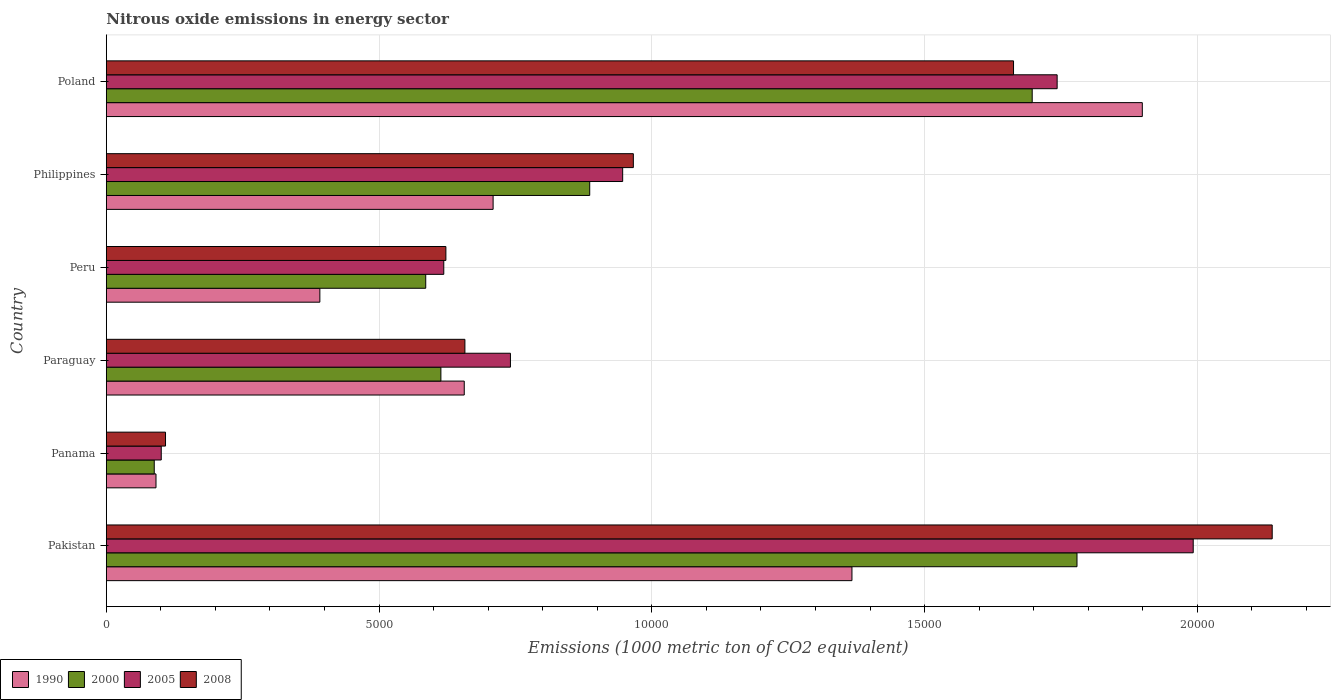How many different coloured bars are there?
Your answer should be compact. 4. How many groups of bars are there?
Your response must be concise. 6. Are the number of bars per tick equal to the number of legend labels?
Provide a succinct answer. Yes. How many bars are there on the 5th tick from the top?
Provide a succinct answer. 4. How many bars are there on the 3rd tick from the bottom?
Your answer should be compact. 4. In how many cases, is the number of bars for a given country not equal to the number of legend labels?
Give a very brief answer. 0. What is the amount of nitrous oxide emitted in 2005 in Panama?
Provide a succinct answer. 1006.8. Across all countries, what is the maximum amount of nitrous oxide emitted in 1990?
Keep it short and to the point. 1.90e+04. Across all countries, what is the minimum amount of nitrous oxide emitted in 1990?
Provide a succinct answer. 910.4. In which country was the amount of nitrous oxide emitted in 1990 minimum?
Ensure brevity in your answer.  Panama. What is the total amount of nitrous oxide emitted in 2008 in the graph?
Ensure brevity in your answer.  6.15e+04. What is the difference between the amount of nitrous oxide emitted in 1990 in Pakistan and that in Paraguay?
Your answer should be compact. 7107. What is the difference between the amount of nitrous oxide emitted in 2005 in Panama and the amount of nitrous oxide emitted in 2008 in Philippines?
Provide a succinct answer. -8654. What is the average amount of nitrous oxide emitted in 1990 per country?
Offer a very short reply. 8522.47. What is the difference between the amount of nitrous oxide emitted in 2000 and amount of nitrous oxide emitted in 2005 in Panama?
Your response must be concise. -128.4. What is the ratio of the amount of nitrous oxide emitted in 1990 in Paraguay to that in Philippines?
Your answer should be very brief. 0.93. Is the difference between the amount of nitrous oxide emitted in 2000 in Paraguay and Poland greater than the difference between the amount of nitrous oxide emitted in 2005 in Paraguay and Poland?
Provide a short and direct response. No. What is the difference between the highest and the second highest amount of nitrous oxide emitted in 2000?
Provide a succinct answer. 821. What is the difference between the highest and the lowest amount of nitrous oxide emitted in 1990?
Ensure brevity in your answer.  1.81e+04. What does the 4th bar from the top in Paraguay represents?
Keep it short and to the point. 1990. What does the 1st bar from the bottom in Philippines represents?
Make the answer very short. 1990. Is it the case that in every country, the sum of the amount of nitrous oxide emitted in 2000 and amount of nitrous oxide emitted in 2008 is greater than the amount of nitrous oxide emitted in 1990?
Give a very brief answer. Yes. How many bars are there?
Ensure brevity in your answer.  24. Are all the bars in the graph horizontal?
Provide a short and direct response. Yes. How many countries are there in the graph?
Your answer should be compact. 6. Does the graph contain any zero values?
Your answer should be very brief. No. Where does the legend appear in the graph?
Keep it short and to the point. Bottom left. What is the title of the graph?
Keep it short and to the point. Nitrous oxide emissions in energy sector. Does "1960" appear as one of the legend labels in the graph?
Give a very brief answer. No. What is the label or title of the X-axis?
Provide a succinct answer. Emissions (1000 metric ton of CO2 equivalent). What is the label or title of the Y-axis?
Make the answer very short. Country. What is the Emissions (1000 metric ton of CO2 equivalent) of 1990 in Pakistan?
Offer a very short reply. 1.37e+04. What is the Emissions (1000 metric ton of CO2 equivalent) of 2000 in Pakistan?
Give a very brief answer. 1.78e+04. What is the Emissions (1000 metric ton of CO2 equivalent) of 2005 in Pakistan?
Offer a very short reply. 1.99e+04. What is the Emissions (1000 metric ton of CO2 equivalent) of 2008 in Pakistan?
Your answer should be very brief. 2.14e+04. What is the Emissions (1000 metric ton of CO2 equivalent) in 1990 in Panama?
Ensure brevity in your answer.  910.4. What is the Emissions (1000 metric ton of CO2 equivalent) of 2000 in Panama?
Ensure brevity in your answer.  878.4. What is the Emissions (1000 metric ton of CO2 equivalent) in 2005 in Panama?
Provide a succinct answer. 1006.8. What is the Emissions (1000 metric ton of CO2 equivalent) of 2008 in Panama?
Provide a succinct answer. 1084.9. What is the Emissions (1000 metric ton of CO2 equivalent) in 1990 in Paraguay?
Provide a short and direct response. 6561.2. What is the Emissions (1000 metric ton of CO2 equivalent) of 2000 in Paraguay?
Give a very brief answer. 6132.8. What is the Emissions (1000 metric ton of CO2 equivalent) in 2005 in Paraguay?
Make the answer very short. 7407.7. What is the Emissions (1000 metric ton of CO2 equivalent) in 2008 in Paraguay?
Your answer should be very brief. 6573. What is the Emissions (1000 metric ton of CO2 equivalent) of 1990 in Peru?
Make the answer very short. 3914.1. What is the Emissions (1000 metric ton of CO2 equivalent) in 2000 in Peru?
Provide a succinct answer. 5854.9. What is the Emissions (1000 metric ton of CO2 equivalent) in 2005 in Peru?
Make the answer very short. 6185.8. What is the Emissions (1000 metric ton of CO2 equivalent) in 2008 in Peru?
Ensure brevity in your answer.  6224.5. What is the Emissions (1000 metric ton of CO2 equivalent) of 1990 in Philippines?
Make the answer very short. 7090.2. What is the Emissions (1000 metric ton of CO2 equivalent) of 2000 in Philippines?
Your response must be concise. 8861.1. What is the Emissions (1000 metric ton of CO2 equivalent) in 2005 in Philippines?
Offer a terse response. 9465.1. What is the Emissions (1000 metric ton of CO2 equivalent) in 2008 in Philippines?
Offer a terse response. 9660.8. What is the Emissions (1000 metric ton of CO2 equivalent) of 1990 in Poland?
Offer a very short reply. 1.90e+04. What is the Emissions (1000 metric ton of CO2 equivalent) of 2000 in Poland?
Your response must be concise. 1.70e+04. What is the Emissions (1000 metric ton of CO2 equivalent) in 2005 in Poland?
Your answer should be compact. 1.74e+04. What is the Emissions (1000 metric ton of CO2 equivalent) in 2008 in Poland?
Offer a terse response. 1.66e+04. Across all countries, what is the maximum Emissions (1000 metric ton of CO2 equivalent) in 1990?
Your answer should be compact. 1.90e+04. Across all countries, what is the maximum Emissions (1000 metric ton of CO2 equivalent) of 2000?
Offer a terse response. 1.78e+04. Across all countries, what is the maximum Emissions (1000 metric ton of CO2 equivalent) of 2005?
Offer a terse response. 1.99e+04. Across all countries, what is the maximum Emissions (1000 metric ton of CO2 equivalent) in 2008?
Your answer should be compact. 2.14e+04. Across all countries, what is the minimum Emissions (1000 metric ton of CO2 equivalent) of 1990?
Keep it short and to the point. 910.4. Across all countries, what is the minimum Emissions (1000 metric ton of CO2 equivalent) in 2000?
Provide a short and direct response. 878.4. Across all countries, what is the minimum Emissions (1000 metric ton of CO2 equivalent) of 2005?
Provide a succinct answer. 1006.8. Across all countries, what is the minimum Emissions (1000 metric ton of CO2 equivalent) in 2008?
Your response must be concise. 1084.9. What is the total Emissions (1000 metric ton of CO2 equivalent) in 1990 in the graph?
Your response must be concise. 5.11e+04. What is the total Emissions (1000 metric ton of CO2 equivalent) in 2000 in the graph?
Your answer should be very brief. 5.65e+04. What is the total Emissions (1000 metric ton of CO2 equivalent) in 2005 in the graph?
Your answer should be compact. 6.14e+04. What is the total Emissions (1000 metric ton of CO2 equivalent) of 2008 in the graph?
Give a very brief answer. 6.15e+04. What is the difference between the Emissions (1000 metric ton of CO2 equivalent) in 1990 in Pakistan and that in Panama?
Your response must be concise. 1.28e+04. What is the difference between the Emissions (1000 metric ton of CO2 equivalent) in 2000 in Pakistan and that in Panama?
Offer a terse response. 1.69e+04. What is the difference between the Emissions (1000 metric ton of CO2 equivalent) in 2005 in Pakistan and that in Panama?
Your answer should be very brief. 1.89e+04. What is the difference between the Emissions (1000 metric ton of CO2 equivalent) of 2008 in Pakistan and that in Panama?
Provide a succinct answer. 2.03e+04. What is the difference between the Emissions (1000 metric ton of CO2 equivalent) in 1990 in Pakistan and that in Paraguay?
Give a very brief answer. 7107. What is the difference between the Emissions (1000 metric ton of CO2 equivalent) of 2000 in Pakistan and that in Paraguay?
Make the answer very short. 1.17e+04. What is the difference between the Emissions (1000 metric ton of CO2 equivalent) in 2005 in Pakistan and that in Paraguay?
Ensure brevity in your answer.  1.25e+04. What is the difference between the Emissions (1000 metric ton of CO2 equivalent) of 2008 in Pakistan and that in Paraguay?
Offer a very short reply. 1.48e+04. What is the difference between the Emissions (1000 metric ton of CO2 equivalent) of 1990 in Pakistan and that in Peru?
Make the answer very short. 9754.1. What is the difference between the Emissions (1000 metric ton of CO2 equivalent) in 2000 in Pakistan and that in Peru?
Your response must be concise. 1.19e+04. What is the difference between the Emissions (1000 metric ton of CO2 equivalent) of 2005 in Pakistan and that in Peru?
Give a very brief answer. 1.37e+04. What is the difference between the Emissions (1000 metric ton of CO2 equivalent) in 2008 in Pakistan and that in Peru?
Your answer should be very brief. 1.51e+04. What is the difference between the Emissions (1000 metric ton of CO2 equivalent) in 1990 in Pakistan and that in Philippines?
Ensure brevity in your answer.  6578. What is the difference between the Emissions (1000 metric ton of CO2 equivalent) of 2000 in Pakistan and that in Philippines?
Offer a very short reply. 8932.4. What is the difference between the Emissions (1000 metric ton of CO2 equivalent) in 2005 in Pakistan and that in Philippines?
Make the answer very short. 1.05e+04. What is the difference between the Emissions (1000 metric ton of CO2 equivalent) in 2008 in Pakistan and that in Philippines?
Offer a very short reply. 1.17e+04. What is the difference between the Emissions (1000 metric ton of CO2 equivalent) of 1990 in Pakistan and that in Poland?
Offer a very short reply. -5322.5. What is the difference between the Emissions (1000 metric ton of CO2 equivalent) in 2000 in Pakistan and that in Poland?
Ensure brevity in your answer.  821. What is the difference between the Emissions (1000 metric ton of CO2 equivalent) of 2005 in Pakistan and that in Poland?
Make the answer very short. 2494.4. What is the difference between the Emissions (1000 metric ton of CO2 equivalent) of 2008 in Pakistan and that in Poland?
Give a very brief answer. 4741.7. What is the difference between the Emissions (1000 metric ton of CO2 equivalent) in 1990 in Panama and that in Paraguay?
Your answer should be compact. -5650.8. What is the difference between the Emissions (1000 metric ton of CO2 equivalent) of 2000 in Panama and that in Paraguay?
Offer a terse response. -5254.4. What is the difference between the Emissions (1000 metric ton of CO2 equivalent) of 2005 in Panama and that in Paraguay?
Your response must be concise. -6400.9. What is the difference between the Emissions (1000 metric ton of CO2 equivalent) in 2008 in Panama and that in Paraguay?
Keep it short and to the point. -5488.1. What is the difference between the Emissions (1000 metric ton of CO2 equivalent) in 1990 in Panama and that in Peru?
Your response must be concise. -3003.7. What is the difference between the Emissions (1000 metric ton of CO2 equivalent) in 2000 in Panama and that in Peru?
Make the answer very short. -4976.5. What is the difference between the Emissions (1000 metric ton of CO2 equivalent) of 2005 in Panama and that in Peru?
Provide a short and direct response. -5179. What is the difference between the Emissions (1000 metric ton of CO2 equivalent) of 2008 in Panama and that in Peru?
Make the answer very short. -5139.6. What is the difference between the Emissions (1000 metric ton of CO2 equivalent) of 1990 in Panama and that in Philippines?
Offer a terse response. -6179.8. What is the difference between the Emissions (1000 metric ton of CO2 equivalent) of 2000 in Panama and that in Philippines?
Your answer should be compact. -7982.7. What is the difference between the Emissions (1000 metric ton of CO2 equivalent) in 2005 in Panama and that in Philippines?
Your answer should be compact. -8458.3. What is the difference between the Emissions (1000 metric ton of CO2 equivalent) of 2008 in Panama and that in Philippines?
Keep it short and to the point. -8575.9. What is the difference between the Emissions (1000 metric ton of CO2 equivalent) in 1990 in Panama and that in Poland?
Your answer should be compact. -1.81e+04. What is the difference between the Emissions (1000 metric ton of CO2 equivalent) in 2000 in Panama and that in Poland?
Your answer should be compact. -1.61e+04. What is the difference between the Emissions (1000 metric ton of CO2 equivalent) of 2005 in Panama and that in Poland?
Your answer should be very brief. -1.64e+04. What is the difference between the Emissions (1000 metric ton of CO2 equivalent) of 2008 in Panama and that in Poland?
Ensure brevity in your answer.  -1.55e+04. What is the difference between the Emissions (1000 metric ton of CO2 equivalent) in 1990 in Paraguay and that in Peru?
Make the answer very short. 2647.1. What is the difference between the Emissions (1000 metric ton of CO2 equivalent) of 2000 in Paraguay and that in Peru?
Provide a short and direct response. 277.9. What is the difference between the Emissions (1000 metric ton of CO2 equivalent) in 2005 in Paraguay and that in Peru?
Keep it short and to the point. 1221.9. What is the difference between the Emissions (1000 metric ton of CO2 equivalent) of 2008 in Paraguay and that in Peru?
Give a very brief answer. 348.5. What is the difference between the Emissions (1000 metric ton of CO2 equivalent) in 1990 in Paraguay and that in Philippines?
Provide a succinct answer. -529. What is the difference between the Emissions (1000 metric ton of CO2 equivalent) of 2000 in Paraguay and that in Philippines?
Keep it short and to the point. -2728.3. What is the difference between the Emissions (1000 metric ton of CO2 equivalent) of 2005 in Paraguay and that in Philippines?
Ensure brevity in your answer.  -2057.4. What is the difference between the Emissions (1000 metric ton of CO2 equivalent) in 2008 in Paraguay and that in Philippines?
Your response must be concise. -3087.8. What is the difference between the Emissions (1000 metric ton of CO2 equivalent) in 1990 in Paraguay and that in Poland?
Give a very brief answer. -1.24e+04. What is the difference between the Emissions (1000 metric ton of CO2 equivalent) in 2000 in Paraguay and that in Poland?
Your response must be concise. -1.08e+04. What is the difference between the Emissions (1000 metric ton of CO2 equivalent) in 2005 in Paraguay and that in Poland?
Offer a very short reply. -1.00e+04. What is the difference between the Emissions (1000 metric ton of CO2 equivalent) of 2008 in Paraguay and that in Poland?
Provide a short and direct response. -1.01e+04. What is the difference between the Emissions (1000 metric ton of CO2 equivalent) in 1990 in Peru and that in Philippines?
Offer a very short reply. -3176.1. What is the difference between the Emissions (1000 metric ton of CO2 equivalent) in 2000 in Peru and that in Philippines?
Provide a succinct answer. -3006.2. What is the difference between the Emissions (1000 metric ton of CO2 equivalent) of 2005 in Peru and that in Philippines?
Ensure brevity in your answer.  -3279.3. What is the difference between the Emissions (1000 metric ton of CO2 equivalent) of 2008 in Peru and that in Philippines?
Offer a terse response. -3436.3. What is the difference between the Emissions (1000 metric ton of CO2 equivalent) of 1990 in Peru and that in Poland?
Your answer should be very brief. -1.51e+04. What is the difference between the Emissions (1000 metric ton of CO2 equivalent) of 2000 in Peru and that in Poland?
Your response must be concise. -1.11e+04. What is the difference between the Emissions (1000 metric ton of CO2 equivalent) of 2005 in Peru and that in Poland?
Your answer should be very brief. -1.12e+04. What is the difference between the Emissions (1000 metric ton of CO2 equivalent) in 2008 in Peru and that in Poland?
Offer a terse response. -1.04e+04. What is the difference between the Emissions (1000 metric ton of CO2 equivalent) in 1990 in Philippines and that in Poland?
Your response must be concise. -1.19e+04. What is the difference between the Emissions (1000 metric ton of CO2 equivalent) in 2000 in Philippines and that in Poland?
Provide a succinct answer. -8111.4. What is the difference between the Emissions (1000 metric ton of CO2 equivalent) in 2005 in Philippines and that in Poland?
Make the answer very short. -7964.5. What is the difference between the Emissions (1000 metric ton of CO2 equivalent) of 2008 in Philippines and that in Poland?
Provide a short and direct response. -6969.3. What is the difference between the Emissions (1000 metric ton of CO2 equivalent) in 1990 in Pakistan and the Emissions (1000 metric ton of CO2 equivalent) in 2000 in Panama?
Your answer should be very brief. 1.28e+04. What is the difference between the Emissions (1000 metric ton of CO2 equivalent) in 1990 in Pakistan and the Emissions (1000 metric ton of CO2 equivalent) in 2005 in Panama?
Your response must be concise. 1.27e+04. What is the difference between the Emissions (1000 metric ton of CO2 equivalent) in 1990 in Pakistan and the Emissions (1000 metric ton of CO2 equivalent) in 2008 in Panama?
Offer a very short reply. 1.26e+04. What is the difference between the Emissions (1000 metric ton of CO2 equivalent) of 2000 in Pakistan and the Emissions (1000 metric ton of CO2 equivalent) of 2005 in Panama?
Provide a short and direct response. 1.68e+04. What is the difference between the Emissions (1000 metric ton of CO2 equivalent) in 2000 in Pakistan and the Emissions (1000 metric ton of CO2 equivalent) in 2008 in Panama?
Keep it short and to the point. 1.67e+04. What is the difference between the Emissions (1000 metric ton of CO2 equivalent) of 2005 in Pakistan and the Emissions (1000 metric ton of CO2 equivalent) of 2008 in Panama?
Your answer should be compact. 1.88e+04. What is the difference between the Emissions (1000 metric ton of CO2 equivalent) of 1990 in Pakistan and the Emissions (1000 metric ton of CO2 equivalent) of 2000 in Paraguay?
Your answer should be very brief. 7535.4. What is the difference between the Emissions (1000 metric ton of CO2 equivalent) of 1990 in Pakistan and the Emissions (1000 metric ton of CO2 equivalent) of 2005 in Paraguay?
Your answer should be compact. 6260.5. What is the difference between the Emissions (1000 metric ton of CO2 equivalent) of 1990 in Pakistan and the Emissions (1000 metric ton of CO2 equivalent) of 2008 in Paraguay?
Provide a short and direct response. 7095.2. What is the difference between the Emissions (1000 metric ton of CO2 equivalent) in 2000 in Pakistan and the Emissions (1000 metric ton of CO2 equivalent) in 2005 in Paraguay?
Your answer should be compact. 1.04e+04. What is the difference between the Emissions (1000 metric ton of CO2 equivalent) of 2000 in Pakistan and the Emissions (1000 metric ton of CO2 equivalent) of 2008 in Paraguay?
Ensure brevity in your answer.  1.12e+04. What is the difference between the Emissions (1000 metric ton of CO2 equivalent) of 2005 in Pakistan and the Emissions (1000 metric ton of CO2 equivalent) of 2008 in Paraguay?
Keep it short and to the point. 1.34e+04. What is the difference between the Emissions (1000 metric ton of CO2 equivalent) of 1990 in Pakistan and the Emissions (1000 metric ton of CO2 equivalent) of 2000 in Peru?
Your response must be concise. 7813.3. What is the difference between the Emissions (1000 metric ton of CO2 equivalent) of 1990 in Pakistan and the Emissions (1000 metric ton of CO2 equivalent) of 2005 in Peru?
Your answer should be compact. 7482.4. What is the difference between the Emissions (1000 metric ton of CO2 equivalent) of 1990 in Pakistan and the Emissions (1000 metric ton of CO2 equivalent) of 2008 in Peru?
Your answer should be compact. 7443.7. What is the difference between the Emissions (1000 metric ton of CO2 equivalent) in 2000 in Pakistan and the Emissions (1000 metric ton of CO2 equivalent) in 2005 in Peru?
Give a very brief answer. 1.16e+04. What is the difference between the Emissions (1000 metric ton of CO2 equivalent) of 2000 in Pakistan and the Emissions (1000 metric ton of CO2 equivalent) of 2008 in Peru?
Make the answer very short. 1.16e+04. What is the difference between the Emissions (1000 metric ton of CO2 equivalent) in 2005 in Pakistan and the Emissions (1000 metric ton of CO2 equivalent) in 2008 in Peru?
Make the answer very short. 1.37e+04. What is the difference between the Emissions (1000 metric ton of CO2 equivalent) of 1990 in Pakistan and the Emissions (1000 metric ton of CO2 equivalent) of 2000 in Philippines?
Offer a terse response. 4807.1. What is the difference between the Emissions (1000 metric ton of CO2 equivalent) of 1990 in Pakistan and the Emissions (1000 metric ton of CO2 equivalent) of 2005 in Philippines?
Offer a terse response. 4203.1. What is the difference between the Emissions (1000 metric ton of CO2 equivalent) of 1990 in Pakistan and the Emissions (1000 metric ton of CO2 equivalent) of 2008 in Philippines?
Make the answer very short. 4007.4. What is the difference between the Emissions (1000 metric ton of CO2 equivalent) of 2000 in Pakistan and the Emissions (1000 metric ton of CO2 equivalent) of 2005 in Philippines?
Keep it short and to the point. 8328.4. What is the difference between the Emissions (1000 metric ton of CO2 equivalent) in 2000 in Pakistan and the Emissions (1000 metric ton of CO2 equivalent) in 2008 in Philippines?
Offer a terse response. 8132.7. What is the difference between the Emissions (1000 metric ton of CO2 equivalent) in 2005 in Pakistan and the Emissions (1000 metric ton of CO2 equivalent) in 2008 in Philippines?
Offer a very short reply. 1.03e+04. What is the difference between the Emissions (1000 metric ton of CO2 equivalent) in 1990 in Pakistan and the Emissions (1000 metric ton of CO2 equivalent) in 2000 in Poland?
Your response must be concise. -3304.3. What is the difference between the Emissions (1000 metric ton of CO2 equivalent) of 1990 in Pakistan and the Emissions (1000 metric ton of CO2 equivalent) of 2005 in Poland?
Offer a terse response. -3761.4. What is the difference between the Emissions (1000 metric ton of CO2 equivalent) in 1990 in Pakistan and the Emissions (1000 metric ton of CO2 equivalent) in 2008 in Poland?
Make the answer very short. -2961.9. What is the difference between the Emissions (1000 metric ton of CO2 equivalent) of 2000 in Pakistan and the Emissions (1000 metric ton of CO2 equivalent) of 2005 in Poland?
Your answer should be very brief. 363.9. What is the difference between the Emissions (1000 metric ton of CO2 equivalent) in 2000 in Pakistan and the Emissions (1000 metric ton of CO2 equivalent) in 2008 in Poland?
Your answer should be compact. 1163.4. What is the difference between the Emissions (1000 metric ton of CO2 equivalent) of 2005 in Pakistan and the Emissions (1000 metric ton of CO2 equivalent) of 2008 in Poland?
Offer a terse response. 3293.9. What is the difference between the Emissions (1000 metric ton of CO2 equivalent) of 1990 in Panama and the Emissions (1000 metric ton of CO2 equivalent) of 2000 in Paraguay?
Provide a succinct answer. -5222.4. What is the difference between the Emissions (1000 metric ton of CO2 equivalent) in 1990 in Panama and the Emissions (1000 metric ton of CO2 equivalent) in 2005 in Paraguay?
Your answer should be very brief. -6497.3. What is the difference between the Emissions (1000 metric ton of CO2 equivalent) of 1990 in Panama and the Emissions (1000 metric ton of CO2 equivalent) of 2008 in Paraguay?
Keep it short and to the point. -5662.6. What is the difference between the Emissions (1000 metric ton of CO2 equivalent) of 2000 in Panama and the Emissions (1000 metric ton of CO2 equivalent) of 2005 in Paraguay?
Offer a terse response. -6529.3. What is the difference between the Emissions (1000 metric ton of CO2 equivalent) in 2000 in Panama and the Emissions (1000 metric ton of CO2 equivalent) in 2008 in Paraguay?
Provide a short and direct response. -5694.6. What is the difference between the Emissions (1000 metric ton of CO2 equivalent) of 2005 in Panama and the Emissions (1000 metric ton of CO2 equivalent) of 2008 in Paraguay?
Offer a terse response. -5566.2. What is the difference between the Emissions (1000 metric ton of CO2 equivalent) of 1990 in Panama and the Emissions (1000 metric ton of CO2 equivalent) of 2000 in Peru?
Make the answer very short. -4944.5. What is the difference between the Emissions (1000 metric ton of CO2 equivalent) of 1990 in Panama and the Emissions (1000 metric ton of CO2 equivalent) of 2005 in Peru?
Give a very brief answer. -5275.4. What is the difference between the Emissions (1000 metric ton of CO2 equivalent) in 1990 in Panama and the Emissions (1000 metric ton of CO2 equivalent) in 2008 in Peru?
Ensure brevity in your answer.  -5314.1. What is the difference between the Emissions (1000 metric ton of CO2 equivalent) in 2000 in Panama and the Emissions (1000 metric ton of CO2 equivalent) in 2005 in Peru?
Your response must be concise. -5307.4. What is the difference between the Emissions (1000 metric ton of CO2 equivalent) in 2000 in Panama and the Emissions (1000 metric ton of CO2 equivalent) in 2008 in Peru?
Give a very brief answer. -5346.1. What is the difference between the Emissions (1000 metric ton of CO2 equivalent) in 2005 in Panama and the Emissions (1000 metric ton of CO2 equivalent) in 2008 in Peru?
Offer a very short reply. -5217.7. What is the difference between the Emissions (1000 metric ton of CO2 equivalent) of 1990 in Panama and the Emissions (1000 metric ton of CO2 equivalent) of 2000 in Philippines?
Offer a terse response. -7950.7. What is the difference between the Emissions (1000 metric ton of CO2 equivalent) in 1990 in Panama and the Emissions (1000 metric ton of CO2 equivalent) in 2005 in Philippines?
Provide a succinct answer. -8554.7. What is the difference between the Emissions (1000 metric ton of CO2 equivalent) of 1990 in Panama and the Emissions (1000 metric ton of CO2 equivalent) of 2008 in Philippines?
Your answer should be very brief. -8750.4. What is the difference between the Emissions (1000 metric ton of CO2 equivalent) in 2000 in Panama and the Emissions (1000 metric ton of CO2 equivalent) in 2005 in Philippines?
Give a very brief answer. -8586.7. What is the difference between the Emissions (1000 metric ton of CO2 equivalent) of 2000 in Panama and the Emissions (1000 metric ton of CO2 equivalent) of 2008 in Philippines?
Provide a succinct answer. -8782.4. What is the difference between the Emissions (1000 metric ton of CO2 equivalent) in 2005 in Panama and the Emissions (1000 metric ton of CO2 equivalent) in 2008 in Philippines?
Make the answer very short. -8654. What is the difference between the Emissions (1000 metric ton of CO2 equivalent) in 1990 in Panama and the Emissions (1000 metric ton of CO2 equivalent) in 2000 in Poland?
Offer a very short reply. -1.61e+04. What is the difference between the Emissions (1000 metric ton of CO2 equivalent) in 1990 in Panama and the Emissions (1000 metric ton of CO2 equivalent) in 2005 in Poland?
Ensure brevity in your answer.  -1.65e+04. What is the difference between the Emissions (1000 metric ton of CO2 equivalent) of 1990 in Panama and the Emissions (1000 metric ton of CO2 equivalent) of 2008 in Poland?
Your answer should be very brief. -1.57e+04. What is the difference between the Emissions (1000 metric ton of CO2 equivalent) in 2000 in Panama and the Emissions (1000 metric ton of CO2 equivalent) in 2005 in Poland?
Make the answer very short. -1.66e+04. What is the difference between the Emissions (1000 metric ton of CO2 equivalent) of 2000 in Panama and the Emissions (1000 metric ton of CO2 equivalent) of 2008 in Poland?
Your answer should be very brief. -1.58e+04. What is the difference between the Emissions (1000 metric ton of CO2 equivalent) in 2005 in Panama and the Emissions (1000 metric ton of CO2 equivalent) in 2008 in Poland?
Your response must be concise. -1.56e+04. What is the difference between the Emissions (1000 metric ton of CO2 equivalent) of 1990 in Paraguay and the Emissions (1000 metric ton of CO2 equivalent) of 2000 in Peru?
Provide a short and direct response. 706.3. What is the difference between the Emissions (1000 metric ton of CO2 equivalent) of 1990 in Paraguay and the Emissions (1000 metric ton of CO2 equivalent) of 2005 in Peru?
Give a very brief answer. 375.4. What is the difference between the Emissions (1000 metric ton of CO2 equivalent) of 1990 in Paraguay and the Emissions (1000 metric ton of CO2 equivalent) of 2008 in Peru?
Provide a short and direct response. 336.7. What is the difference between the Emissions (1000 metric ton of CO2 equivalent) in 2000 in Paraguay and the Emissions (1000 metric ton of CO2 equivalent) in 2005 in Peru?
Ensure brevity in your answer.  -53. What is the difference between the Emissions (1000 metric ton of CO2 equivalent) in 2000 in Paraguay and the Emissions (1000 metric ton of CO2 equivalent) in 2008 in Peru?
Offer a terse response. -91.7. What is the difference between the Emissions (1000 metric ton of CO2 equivalent) in 2005 in Paraguay and the Emissions (1000 metric ton of CO2 equivalent) in 2008 in Peru?
Offer a very short reply. 1183.2. What is the difference between the Emissions (1000 metric ton of CO2 equivalent) of 1990 in Paraguay and the Emissions (1000 metric ton of CO2 equivalent) of 2000 in Philippines?
Your response must be concise. -2299.9. What is the difference between the Emissions (1000 metric ton of CO2 equivalent) of 1990 in Paraguay and the Emissions (1000 metric ton of CO2 equivalent) of 2005 in Philippines?
Offer a very short reply. -2903.9. What is the difference between the Emissions (1000 metric ton of CO2 equivalent) of 1990 in Paraguay and the Emissions (1000 metric ton of CO2 equivalent) of 2008 in Philippines?
Offer a terse response. -3099.6. What is the difference between the Emissions (1000 metric ton of CO2 equivalent) in 2000 in Paraguay and the Emissions (1000 metric ton of CO2 equivalent) in 2005 in Philippines?
Provide a short and direct response. -3332.3. What is the difference between the Emissions (1000 metric ton of CO2 equivalent) of 2000 in Paraguay and the Emissions (1000 metric ton of CO2 equivalent) of 2008 in Philippines?
Provide a succinct answer. -3528. What is the difference between the Emissions (1000 metric ton of CO2 equivalent) in 2005 in Paraguay and the Emissions (1000 metric ton of CO2 equivalent) in 2008 in Philippines?
Make the answer very short. -2253.1. What is the difference between the Emissions (1000 metric ton of CO2 equivalent) in 1990 in Paraguay and the Emissions (1000 metric ton of CO2 equivalent) in 2000 in Poland?
Give a very brief answer. -1.04e+04. What is the difference between the Emissions (1000 metric ton of CO2 equivalent) of 1990 in Paraguay and the Emissions (1000 metric ton of CO2 equivalent) of 2005 in Poland?
Provide a succinct answer. -1.09e+04. What is the difference between the Emissions (1000 metric ton of CO2 equivalent) of 1990 in Paraguay and the Emissions (1000 metric ton of CO2 equivalent) of 2008 in Poland?
Keep it short and to the point. -1.01e+04. What is the difference between the Emissions (1000 metric ton of CO2 equivalent) of 2000 in Paraguay and the Emissions (1000 metric ton of CO2 equivalent) of 2005 in Poland?
Offer a very short reply. -1.13e+04. What is the difference between the Emissions (1000 metric ton of CO2 equivalent) in 2000 in Paraguay and the Emissions (1000 metric ton of CO2 equivalent) in 2008 in Poland?
Make the answer very short. -1.05e+04. What is the difference between the Emissions (1000 metric ton of CO2 equivalent) in 2005 in Paraguay and the Emissions (1000 metric ton of CO2 equivalent) in 2008 in Poland?
Ensure brevity in your answer.  -9222.4. What is the difference between the Emissions (1000 metric ton of CO2 equivalent) of 1990 in Peru and the Emissions (1000 metric ton of CO2 equivalent) of 2000 in Philippines?
Provide a short and direct response. -4947. What is the difference between the Emissions (1000 metric ton of CO2 equivalent) of 1990 in Peru and the Emissions (1000 metric ton of CO2 equivalent) of 2005 in Philippines?
Offer a terse response. -5551. What is the difference between the Emissions (1000 metric ton of CO2 equivalent) of 1990 in Peru and the Emissions (1000 metric ton of CO2 equivalent) of 2008 in Philippines?
Your answer should be compact. -5746.7. What is the difference between the Emissions (1000 metric ton of CO2 equivalent) in 2000 in Peru and the Emissions (1000 metric ton of CO2 equivalent) in 2005 in Philippines?
Your answer should be very brief. -3610.2. What is the difference between the Emissions (1000 metric ton of CO2 equivalent) of 2000 in Peru and the Emissions (1000 metric ton of CO2 equivalent) of 2008 in Philippines?
Provide a short and direct response. -3805.9. What is the difference between the Emissions (1000 metric ton of CO2 equivalent) in 2005 in Peru and the Emissions (1000 metric ton of CO2 equivalent) in 2008 in Philippines?
Your answer should be compact. -3475. What is the difference between the Emissions (1000 metric ton of CO2 equivalent) of 1990 in Peru and the Emissions (1000 metric ton of CO2 equivalent) of 2000 in Poland?
Your answer should be compact. -1.31e+04. What is the difference between the Emissions (1000 metric ton of CO2 equivalent) in 1990 in Peru and the Emissions (1000 metric ton of CO2 equivalent) in 2005 in Poland?
Offer a very short reply. -1.35e+04. What is the difference between the Emissions (1000 metric ton of CO2 equivalent) of 1990 in Peru and the Emissions (1000 metric ton of CO2 equivalent) of 2008 in Poland?
Provide a succinct answer. -1.27e+04. What is the difference between the Emissions (1000 metric ton of CO2 equivalent) in 2000 in Peru and the Emissions (1000 metric ton of CO2 equivalent) in 2005 in Poland?
Offer a terse response. -1.16e+04. What is the difference between the Emissions (1000 metric ton of CO2 equivalent) of 2000 in Peru and the Emissions (1000 metric ton of CO2 equivalent) of 2008 in Poland?
Make the answer very short. -1.08e+04. What is the difference between the Emissions (1000 metric ton of CO2 equivalent) of 2005 in Peru and the Emissions (1000 metric ton of CO2 equivalent) of 2008 in Poland?
Provide a short and direct response. -1.04e+04. What is the difference between the Emissions (1000 metric ton of CO2 equivalent) in 1990 in Philippines and the Emissions (1000 metric ton of CO2 equivalent) in 2000 in Poland?
Make the answer very short. -9882.3. What is the difference between the Emissions (1000 metric ton of CO2 equivalent) in 1990 in Philippines and the Emissions (1000 metric ton of CO2 equivalent) in 2005 in Poland?
Offer a very short reply. -1.03e+04. What is the difference between the Emissions (1000 metric ton of CO2 equivalent) of 1990 in Philippines and the Emissions (1000 metric ton of CO2 equivalent) of 2008 in Poland?
Give a very brief answer. -9539.9. What is the difference between the Emissions (1000 metric ton of CO2 equivalent) of 2000 in Philippines and the Emissions (1000 metric ton of CO2 equivalent) of 2005 in Poland?
Make the answer very short. -8568.5. What is the difference between the Emissions (1000 metric ton of CO2 equivalent) of 2000 in Philippines and the Emissions (1000 metric ton of CO2 equivalent) of 2008 in Poland?
Keep it short and to the point. -7769. What is the difference between the Emissions (1000 metric ton of CO2 equivalent) in 2005 in Philippines and the Emissions (1000 metric ton of CO2 equivalent) in 2008 in Poland?
Provide a succinct answer. -7165. What is the average Emissions (1000 metric ton of CO2 equivalent) in 1990 per country?
Make the answer very short. 8522.47. What is the average Emissions (1000 metric ton of CO2 equivalent) in 2000 per country?
Your answer should be very brief. 9415.53. What is the average Emissions (1000 metric ton of CO2 equivalent) in 2005 per country?
Provide a succinct answer. 1.02e+04. What is the average Emissions (1000 metric ton of CO2 equivalent) in 2008 per country?
Offer a terse response. 1.03e+04. What is the difference between the Emissions (1000 metric ton of CO2 equivalent) in 1990 and Emissions (1000 metric ton of CO2 equivalent) in 2000 in Pakistan?
Your answer should be very brief. -4125.3. What is the difference between the Emissions (1000 metric ton of CO2 equivalent) in 1990 and Emissions (1000 metric ton of CO2 equivalent) in 2005 in Pakistan?
Your answer should be compact. -6255.8. What is the difference between the Emissions (1000 metric ton of CO2 equivalent) in 1990 and Emissions (1000 metric ton of CO2 equivalent) in 2008 in Pakistan?
Offer a terse response. -7703.6. What is the difference between the Emissions (1000 metric ton of CO2 equivalent) of 2000 and Emissions (1000 metric ton of CO2 equivalent) of 2005 in Pakistan?
Your response must be concise. -2130.5. What is the difference between the Emissions (1000 metric ton of CO2 equivalent) of 2000 and Emissions (1000 metric ton of CO2 equivalent) of 2008 in Pakistan?
Keep it short and to the point. -3578.3. What is the difference between the Emissions (1000 metric ton of CO2 equivalent) in 2005 and Emissions (1000 metric ton of CO2 equivalent) in 2008 in Pakistan?
Keep it short and to the point. -1447.8. What is the difference between the Emissions (1000 metric ton of CO2 equivalent) in 1990 and Emissions (1000 metric ton of CO2 equivalent) in 2005 in Panama?
Give a very brief answer. -96.4. What is the difference between the Emissions (1000 metric ton of CO2 equivalent) in 1990 and Emissions (1000 metric ton of CO2 equivalent) in 2008 in Panama?
Ensure brevity in your answer.  -174.5. What is the difference between the Emissions (1000 metric ton of CO2 equivalent) of 2000 and Emissions (1000 metric ton of CO2 equivalent) of 2005 in Panama?
Provide a succinct answer. -128.4. What is the difference between the Emissions (1000 metric ton of CO2 equivalent) in 2000 and Emissions (1000 metric ton of CO2 equivalent) in 2008 in Panama?
Provide a short and direct response. -206.5. What is the difference between the Emissions (1000 metric ton of CO2 equivalent) of 2005 and Emissions (1000 metric ton of CO2 equivalent) of 2008 in Panama?
Keep it short and to the point. -78.1. What is the difference between the Emissions (1000 metric ton of CO2 equivalent) of 1990 and Emissions (1000 metric ton of CO2 equivalent) of 2000 in Paraguay?
Make the answer very short. 428.4. What is the difference between the Emissions (1000 metric ton of CO2 equivalent) in 1990 and Emissions (1000 metric ton of CO2 equivalent) in 2005 in Paraguay?
Offer a terse response. -846.5. What is the difference between the Emissions (1000 metric ton of CO2 equivalent) in 2000 and Emissions (1000 metric ton of CO2 equivalent) in 2005 in Paraguay?
Offer a terse response. -1274.9. What is the difference between the Emissions (1000 metric ton of CO2 equivalent) in 2000 and Emissions (1000 metric ton of CO2 equivalent) in 2008 in Paraguay?
Give a very brief answer. -440.2. What is the difference between the Emissions (1000 metric ton of CO2 equivalent) of 2005 and Emissions (1000 metric ton of CO2 equivalent) of 2008 in Paraguay?
Your answer should be compact. 834.7. What is the difference between the Emissions (1000 metric ton of CO2 equivalent) in 1990 and Emissions (1000 metric ton of CO2 equivalent) in 2000 in Peru?
Your answer should be compact. -1940.8. What is the difference between the Emissions (1000 metric ton of CO2 equivalent) of 1990 and Emissions (1000 metric ton of CO2 equivalent) of 2005 in Peru?
Your response must be concise. -2271.7. What is the difference between the Emissions (1000 metric ton of CO2 equivalent) of 1990 and Emissions (1000 metric ton of CO2 equivalent) of 2008 in Peru?
Your answer should be compact. -2310.4. What is the difference between the Emissions (1000 metric ton of CO2 equivalent) in 2000 and Emissions (1000 metric ton of CO2 equivalent) in 2005 in Peru?
Keep it short and to the point. -330.9. What is the difference between the Emissions (1000 metric ton of CO2 equivalent) of 2000 and Emissions (1000 metric ton of CO2 equivalent) of 2008 in Peru?
Give a very brief answer. -369.6. What is the difference between the Emissions (1000 metric ton of CO2 equivalent) in 2005 and Emissions (1000 metric ton of CO2 equivalent) in 2008 in Peru?
Give a very brief answer. -38.7. What is the difference between the Emissions (1000 metric ton of CO2 equivalent) in 1990 and Emissions (1000 metric ton of CO2 equivalent) in 2000 in Philippines?
Offer a terse response. -1770.9. What is the difference between the Emissions (1000 metric ton of CO2 equivalent) of 1990 and Emissions (1000 metric ton of CO2 equivalent) of 2005 in Philippines?
Offer a terse response. -2374.9. What is the difference between the Emissions (1000 metric ton of CO2 equivalent) in 1990 and Emissions (1000 metric ton of CO2 equivalent) in 2008 in Philippines?
Your answer should be compact. -2570.6. What is the difference between the Emissions (1000 metric ton of CO2 equivalent) in 2000 and Emissions (1000 metric ton of CO2 equivalent) in 2005 in Philippines?
Provide a succinct answer. -604. What is the difference between the Emissions (1000 metric ton of CO2 equivalent) in 2000 and Emissions (1000 metric ton of CO2 equivalent) in 2008 in Philippines?
Make the answer very short. -799.7. What is the difference between the Emissions (1000 metric ton of CO2 equivalent) of 2005 and Emissions (1000 metric ton of CO2 equivalent) of 2008 in Philippines?
Your answer should be compact. -195.7. What is the difference between the Emissions (1000 metric ton of CO2 equivalent) in 1990 and Emissions (1000 metric ton of CO2 equivalent) in 2000 in Poland?
Make the answer very short. 2018.2. What is the difference between the Emissions (1000 metric ton of CO2 equivalent) of 1990 and Emissions (1000 metric ton of CO2 equivalent) of 2005 in Poland?
Provide a succinct answer. 1561.1. What is the difference between the Emissions (1000 metric ton of CO2 equivalent) of 1990 and Emissions (1000 metric ton of CO2 equivalent) of 2008 in Poland?
Your answer should be very brief. 2360.6. What is the difference between the Emissions (1000 metric ton of CO2 equivalent) in 2000 and Emissions (1000 metric ton of CO2 equivalent) in 2005 in Poland?
Your answer should be compact. -457.1. What is the difference between the Emissions (1000 metric ton of CO2 equivalent) of 2000 and Emissions (1000 metric ton of CO2 equivalent) of 2008 in Poland?
Make the answer very short. 342.4. What is the difference between the Emissions (1000 metric ton of CO2 equivalent) in 2005 and Emissions (1000 metric ton of CO2 equivalent) in 2008 in Poland?
Your response must be concise. 799.5. What is the ratio of the Emissions (1000 metric ton of CO2 equivalent) of 1990 in Pakistan to that in Panama?
Keep it short and to the point. 15.01. What is the ratio of the Emissions (1000 metric ton of CO2 equivalent) in 2000 in Pakistan to that in Panama?
Ensure brevity in your answer.  20.26. What is the ratio of the Emissions (1000 metric ton of CO2 equivalent) of 2005 in Pakistan to that in Panama?
Provide a succinct answer. 19.79. What is the ratio of the Emissions (1000 metric ton of CO2 equivalent) of 2008 in Pakistan to that in Panama?
Your answer should be compact. 19.7. What is the ratio of the Emissions (1000 metric ton of CO2 equivalent) of 1990 in Pakistan to that in Paraguay?
Provide a short and direct response. 2.08. What is the ratio of the Emissions (1000 metric ton of CO2 equivalent) of 2000 in Pakistan to that in Paraguay?
Your response must be concise. 2.9. What is the ratio of the Emissions (1000 metric ton of CO2 equivalent) in 2005 in Pakistan to that in Paraguay?
Your answer should be compact. 2.69. What is the ratio of the Emissions (1000 metric ton of CO2 equivalent) of 2008 in Pakistan to that in Paraguay?
Your answer should be very brief. 3.25. What is the ratio of the Emissions (1000 metric ton of CO2 equivalent) in 1990 in Pakistan to that in Peru?
Keep it short and to the point. 3.49. What is the ratio of the Emissions (1000 metric ton of CO2 equivalent) of 2000 in Pakistan to that in Peru?
Ensure brevity in your answer.  3.04. What is the ratio of the Emissions (1000 metric ton of CO2 equivalent) in 2005 in Pakistan to that in Peru?
Make the answer very short. 3.22. What is the ratio of the Emissions (1000 metric ton of CO2 equivalent) of 2008 in Pakistan to that in Peru?
Your response must be concise. 3.43. What is the ratio of the Emissions (1000 metric ton of CO2 equivalent) of 1990 in Pakistan to that in Philippines?
Provide a short and direct response. 1.93. What is the ratio of the Emissions (1000 metric ton of CO2 equivalent) in 2000 in Pakistan to that in Philippines?
Keep it short and to the point. 2.01. What is the ratio of the Emissions (1000 metric ton of CO2 equivalent) of 2005 in Pakistan to that in Philippines?
Provide a short and direct response. 2.1. What is the ratio of the Emissions (1000 metric ton of CO2 equivalent) in 2008 in Pakistan to that in Philippines?
Give a very brief answer. 2.21. What is the ratio of the Emissions (1000 metric ton of CO2 equivalent) in 1990 in Pakistan to that in Poland?
Give a very brief answer. 0.72. What is the ratio of the Emissions (1000 metric ton of CO2 equivalent) of 2000 in Pakistan to that in Poland?
Give a very brief answer. 1.05. What is the ratio of the Emissions (1000 metric ton of CO2 equivalent) in 2005 in Pakistan to that in Poland?
Keep it short and to the point. 1.14. What is the ratio of the Emissions (1000 metric ton of CO2 equivalent) in 2008 in Pakistan to that in Poland?
Make the answer very short. 1.29. What is the ratio of the Emissions (1000 metric ton of CO2 equivalent) in 1990 in Panama to that in Paraguay?
Your response must be concise. 0.14. What is the ratio of the Emissions (1000 metric ton of CO2 equivalent) in 2000 in Panama to that in Paraguay?
Make the answer very short. 0.14. What is the ratio of the Emissions (1000 metric ton of CO2 equivalent) in 2005 in Panama to that in Paraguay?
Provide a short and direct response. 0.14. What is the ratio of the Emissions (1000 metric ton of CO2 equivalent) of 2008 in Panama to that in Paraguay?
Offer a very short reply. 0.17. What is the ratio of the Emissions (1000 metric ton of CO2 equivalent) in 1990 in Panama to that in Peru?
Provide a succinct answer. 0.23. What is the ratio of the Emissions (1000 metric ton of CO2 equivalent) in 2000 in Panama to that in Peru?
Make the answer very short. 0.15. What is the ratio of the Emissions (1000 metric ton of CO2 equivalent) of 2005 in Panama to that in Peru?
Keep it short and to the point. 0.16. What is the ratio of the Emissions (1000 metric ton of CO2 equivalent) in 2008 in Panama to that in Peru?
Provide a succinct answer. 0.17. What is the ratio of the Emissions (1000 metric ton of CO2 equivalent) in 1990 in Panama to that in Philippines?
Give a very brief answer. 0.13. What is the ratio of the Emissions (1000 metric ton of CO2 equivalent) in 2000 in Panama to that in Philippines?
Your answer should be very brief. 0.1. What is the ratio of the Emissions (1000 metric ton of CO2 equivalent) in 2005 in Panama to that in Philippines?
Your answer should be compact. 0.11. What is the ratio of the Emissions (1000 metric ton of CO2 equivalent) of 2008 in Panama to that in Philippines?
Offer a terse response. 0.11. What is the ratio of the Emissions (1000 metric ton of CO2 equivalent) of 1990 in Panama to that in Poland?
Keep it short and to the point. 0.05. What is the ratio of the Emissions (1000 metric ton of CO2 equivalent) of 2000 in Panama to that in Poland?
Your answer should be very brief. 0.05. What is the ratio of the Emissions (1000 metric ton of CO2 equivalent) of 2005 in Panama to that in Poland?
Keep it short and to the point. 0.06. What is the ratio of the Emissions (1000 metric ton of CO2 equivalent) in 2008 in Panama to that in Poland?
Ensure brevity in your answer.  0.07. What is the ratio of the Emissions (1000 metric ton of CO2 equivalent) of 1990 in Paraguay to that in Peru?
Provide a succinct answer. 1.68. What is the ratio of the Emissions (1000 metric ton of CO2 equivalent) in 2000 in Paraguay to that in Peru?
Ensure brevity in your answer.  1.05. What is the ratio of the Emissions (1000 metric ton of CO2 equivalent) in 2005 in Paraguay to that in Peru?
Offer a very short reply. 1.2. What is the ratio of the Emissions (1000 metric ton of CO2 equivalent) of 2008 in Paraguay to that in Peru?
Make the answer very short. 1.06. What is the ratio of the Emissions (1000 metric ton of CO2 equivalent) in 1990 in Paraguay to that in Philippines?
Your answer should be compact. 0.93. What is the ratio of the Emissions (1000 metric ton of CO2 equivalent) of 2000 in Paraguay to that in Philippines?
Ensure brevity in your answer.  0.69. What is the ratio of the Emissions (1000 metric ton of CO2 equivalent) of 2005 in Paraguay to that in Philippines?
Provide a short and direct response. 0.78. What is the ratio of the Emissions (1000 metric ton of CO2 equivalent) in 2008 in Paraguay to that in Philippines?
Provide a succinct answer. 0.68. What is the ratio of the Emissions (1000 metric ton of CO2 equivalent) in 1990 in Paraguay to that in Poland?
Provide a succinct answer. 0.35. What is the ratio of the Emissions (1000 metric ton of CO2 equivalent) of 2000 in Paraguay to that in Poland?
Your answer should be compact. 0.36. What is the ratio of the Emissions (1000 metric ton of CO2 equivalent) in 2005 in Paraguay to that in Poland?
Your answer should be very brief. 0.42. What is the ratio of the Emissions (1000 metric ton of CO2 equivalent) of 2008 in Paraguay to that in Poland?
Provide a succinct answer. 0.4. What is the ratio of the Emissions (1000 metric ton of CO2 equivalent) of 1990 in Peru to that in Philippines?
Your response must be concise. 0.55. What is the ratio of the Emissions (1000 metric ton of CO2 equivalent) in 2000 in Peru to that in Philippines?
Keep it short and to the point. 0.66. What is the ratio of the Emissions (1000 metric ton of CO2 equivalent) of 2005 in Peru to that in Philippines?
Provide a succinct answer. 0.65. What is the ratio of the Emissions (1000 metric ton of CO2 equivalent) in 2008 in Peru to that in Philippines?
Provide a succinct answer. 0.64. What is the ratio of the Emissions (1000 metric ton of CO2 equivalent) of 1990 in Peru to that in Poland?
Make the answer very short. 0.21. What is the ratio of the Emissions (1000 metric ton of CO2 equivalent) of 2000 in Peru to that in Poland?
Offer a very short reply. 0.34. What is the ratio of the Emissions (1000 metric ton of CO2 equivalent) of 2005 in Peru to that in Poland?
Keep it short and to the point. 0.35. What is the ratio of the Emissions (1000 metric ton of CO2 equivalent) of 2008 in Peru to that in Poland?
Your answer should be very brief. 0.37. What is the ratio of the Emissions (1000 metric ton of CO2 equivalent) of 1990 in Philippines to that in Poland?
Offer a terse response. 0.37. What is the ratio of the Emissions (1000 metric ton of CO2 equivalent) in 2000 in Philippines to that in Poland?
Ensure brevity in your answer.  0.52. What is the ratio of the Emissions (1000 metric ton of CO2 equivalent) of 2005 in Philippines to that in Poland?
Your answer should be compact. 0.54. What is the ratio of the Emissions (1000 metric ton of CO2 equivalent) in 2008 in Philippines to that in Poland?
Provide a short and direct response. 0.58. What is the difference between the highest and the second highest Emissions (1000 metric ton of CO2 equivalent) of 1990?
Your answer should be compact. 5322.5. What is the difference between the highest and the second highest Emissions (1000 metric ton of CO2 equivalent) of 2000?
Provide a succinct answer. 821. What is the difference between the highest and the second highest Emissions (1000 metric ton of CO2 equivalent) of 2005?
Offer a terse response. 2494.4. What is the difference between the highest and the second highest Emissions (1000 metric ton of CO2 equivalent) in 2008?
Make the answer very short. 4741.7. What is the difference between the highest and the lowest Emissions (1000 metric ton of CO2 equivalent) in 1990?
Provide a short and direct response. 1.81e+04. What is the difference between the highest and the lowest Emissions (1000 metric ton of CO2 equivalent) of 2000?
Your response must be concise. 1.69e+04. What is the difference between the highest and the lowest Emissions (1000 metric ton of CO2 equivalent) in 2005?
Provide a short and direct response. 1.89e+04. What is the difference between the highest and the lowest Emissions (1000 metric ton of CO2 equivalent) in 2008?
Give a very brief answer. 2.03e+04. 